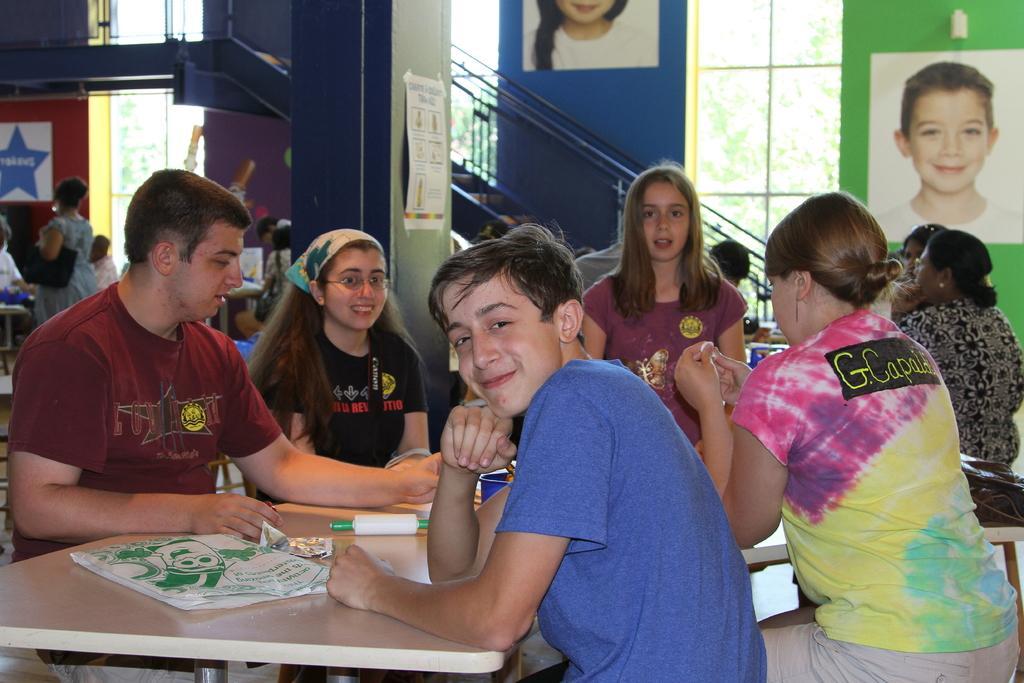Describe this image in one or two sentences. In this image we can see the inner view of a building and there are some people and we can see a table and there are some objects on the table. In the background, we can see the wall with photo frames and there is a stairway and we can see a pillar with a poster. 